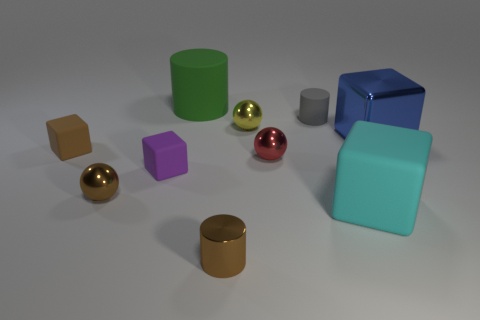There is a metal object in front of the small brown sphere; is it the same color as the large cylinder?
Offer a very short reply. No. What is the size of the purple thing?
Provide a succinct answer. Small. What material is the cyan cube that is the same size as the green cylinder?
Your response must be concise. Rubber. The rubber cube right of the tiny red shiny thing is what color?
Provide a short and direct response. Cyan. How many small yellow metal blocks are there?
Offer a very short reply. 0. Is there a tiny brown metal ball behind the large matte thing behind the tiny rubber object behind the small brown cube?
Provide a succinct answer. No. The blue object that is the same size as the cyan thing is what shape?
Offer a very short reply. Cube. What number of other objects are the same color as the metal cube?
Provide a short and direct response. 0. What material is the large green cylinder?
Provide a succinct answer. Rubber. What number of other objects are there of the same material as the large blue thing?
Make the answer very short. 4. 